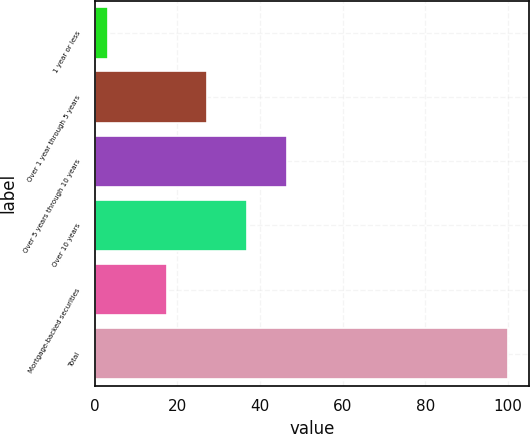Convert chart to OTSL. <chart><loc_0><loc_0><loc_500><loc_500><bar_chart><fcel>1 year or less<fcel>Over 1 year through 5 years<fcel>Over 5 years through 10 years<fcel>Over 10 years<fcel>Mortgage-backed securities<fcel>Total<nl><fcel>3.2<fcel>27.08<fcel>46.44<fcel>36.76<fcel>17.4<fcel>100<nl></chart> 